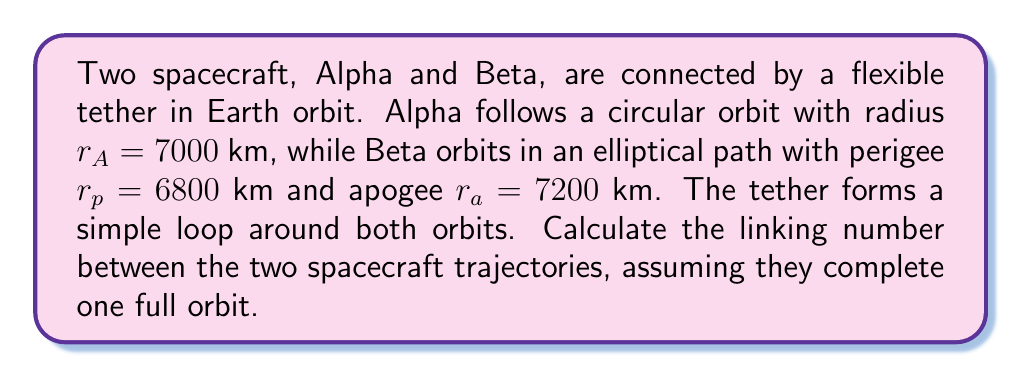What is the answer to this math problem? To compute the linking number, we'll follow these steps:

1) First, we need to understand that the linking number is an integer that describes how many times one closed curve wraps around another in three-dimensional space.

2) In this case, we have two closed curves: the circular orbit of Alpha and the elliptical orbit of Beta.

3) The linking number can be calculated using the Gauss linking integral:

   $$Lk = \frac{1}{4\pi} \oint_{\alpha} \oint_{\beta} \frac{(\mathbf{r}_\alpha - \mathbf{r}_\beta) \cdot (d\mathbf{r}_\alpha \times d\mathbf{r}_\beta)}{|\mathbf{r}_\alpha - \mathbf{r}_\beta|^3}$$

4) However, for simple configurations like this, we can determine the linking number by counting the number of times one curve passes over or under the other, assigning +1 for an over-crossing and -1 for an under-crossing.

5) In this case, the elliptical orbit of Beta will intersect Alpha's circular orbit twice per revolution:
   - Once when Beta is at perigee (inner crossing)
   - Once when Beta is at apogee (outer crossing)

6) Assuming the tether forms a simple loop, it will cause Beta's trajectory to go over Alpha's orbit at one crossing and under at the other.

7) Therefore, we have one +1 and one -1 contribution, which sum to 0.

8) The linking number is the sum of these contributions divided by 2.

Thus, the linking number is 0/2 = 0.
Answer: 0 